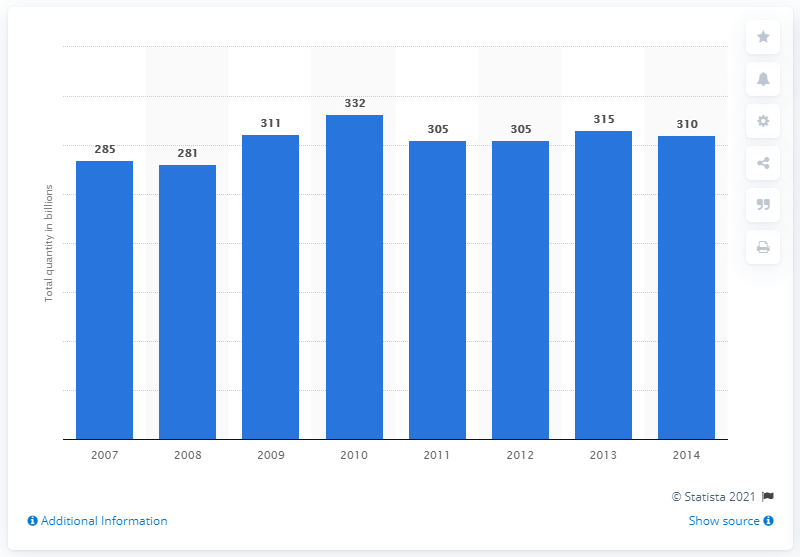Highlight a few significant elements in this photo. In 2011, the CPG coupon distribution volume in the United States was approximately 305 million. 